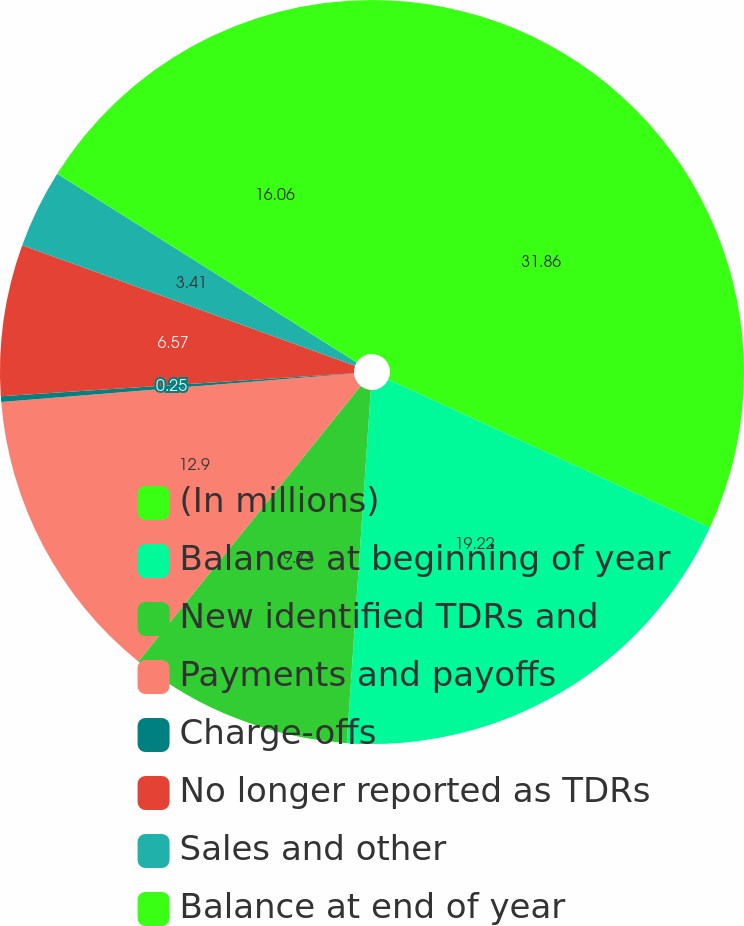<chart> <loc_0><loc_0><loc_500><loc_500><pie_chart><fcel>(In millions)<fcel>Balance at beginning of year<fcel>New identified TDRs and<fcel>Payments and payoffs<fcel>Charge-offs<fcel>No longer reported as TDRs<fcel>Sales and other<fcel>Balance at end of year<nl><fcel>31.86%<fcel>19.22%<fcel>9.73%<fcel>12.9%<fcel>0.25%<fcel>6.57%<fcel>3.41%<fcel>16.06%<nl></chart> 